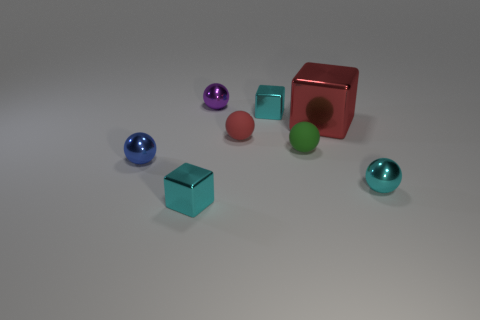Are there fewer metallic spheres than small objects?
Your response must be concise. Yes. Does the purple ball have the same material as the small green object?
Offer a very short reply. No. What number of other objects are the same color as the large cube?
Offer a terse response. 1. Is the number of red cubes greater than the number of green cylinders?
Offer a terse response. Yes. There is a purple metallic thing; is it the same size as the cube that is to the right of the green rubber thing?
Provide a short and direct response. No. There is a tiny cube that is in front of the large red cube; what color is it?
Offer a terse response. Cyan. How many cyan objects are shiny things or rubber objects?
Provide a short and direct response. 3. The big metallic thing has what color?
Provide a succinct answer. Red. Is there any other thing that is made of the same material as the red block?
Ensure brevity in your answer.  Yes. Is the number of big red blocks that are behind the large red block less than the number of red rubber spheres that are left of the small cyan metal ball?
Your response must be concise. Yes. 